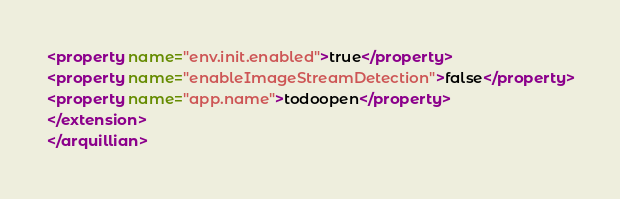<code> <loc_0><loc_0><loc_500><loc_500><_XML_><property name="env.init.enabled">true</property>
<property name="enableImageStreamDetection">false</property>
<property name="app.name">todoopen</property>
</extension>
</arquillian>
</code> 